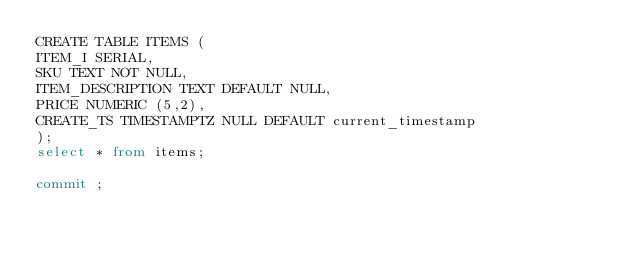Convert code to text. <code><loc_0><loc_0><loc_500><loc_500><_SQL_>CREATE TABLE ITEMS (
ITEM_I SERIAL,
SKU TEXT NOT NULL,
ITEM_DESCRIPTION TEXT DEFAULT NULL,
PRICE NUMERIC (5,2),
CREATE_TS TIMESTAMPTZ NULL DEFAULT current_timestamp
);
select * from items;

commit ;</code> 